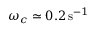Convert formula to latex. <formula><loc_0><loc_0><loc_500><loc_500>\omega _ { c } \simeq 0 . 2 \, { s } ^ { - 1 }</formula> 